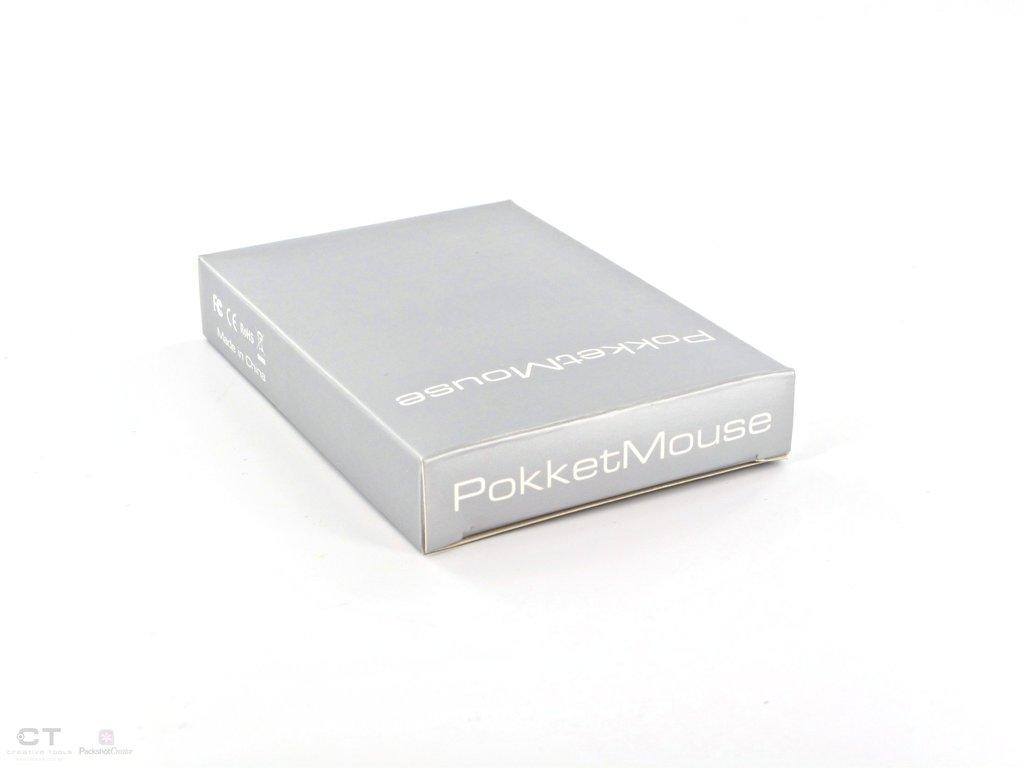Provide a one-sentence caption for the provided image. A PokketMouse package sitting in a white background. 